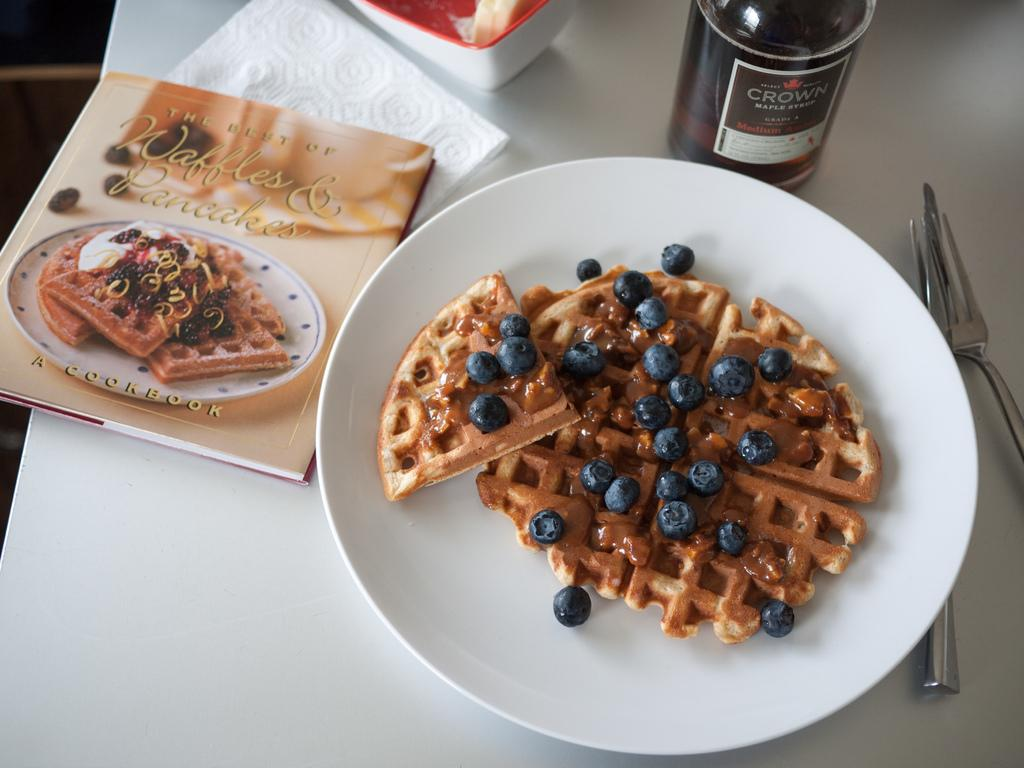What type of furniture is present in the image? There is a table in the image. What is the color of the table? The table is white. What items are placed on the table? There is a plate, a book, a tissue, a bowl, a bottle, and a pancake on the table. What type of road can be seen in the image? There is no road present in the image; it features a table with various items on it. What view is visible from the table in the image? The image does not show a view from the table, as it only shows the table and its contents. 